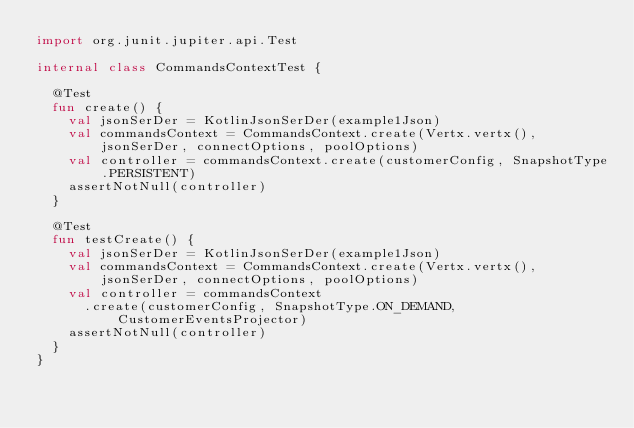Convert code to text. <code><loc_0><loc_0><loc_500><loc_500><_Kotlin_>import org.junit.jupiter.api.Test

internal class CommandsContextTest {

  @Test
  fun create() {
    val jsonSerDer = KotlinJsonSerDer(example1Json)
    val commandsContext = CommandsContext.create(Vertx.vertx(), jsonSerDer, connectOptions, poolOptions)
    val controller = commandsContext.create(customerConfig, SnapshotType.PERSISTENT)
    assertNotNull(controller)
  }

  @Test
  fun testCreate() {
    val jsonSerDer = KotlinJsonSerDer(example1Json)
    val commandsContext = CommandsContext.create(Vertx.vertx(), jsonSerDer, connectOptions, poolOptions)
    val controller = commandsContext
      .create(customerConfig, SnapshotType.ON_DEMAND, CustomerEventsProjector)
    assertNotNull(controller)
  }
}
</code> 